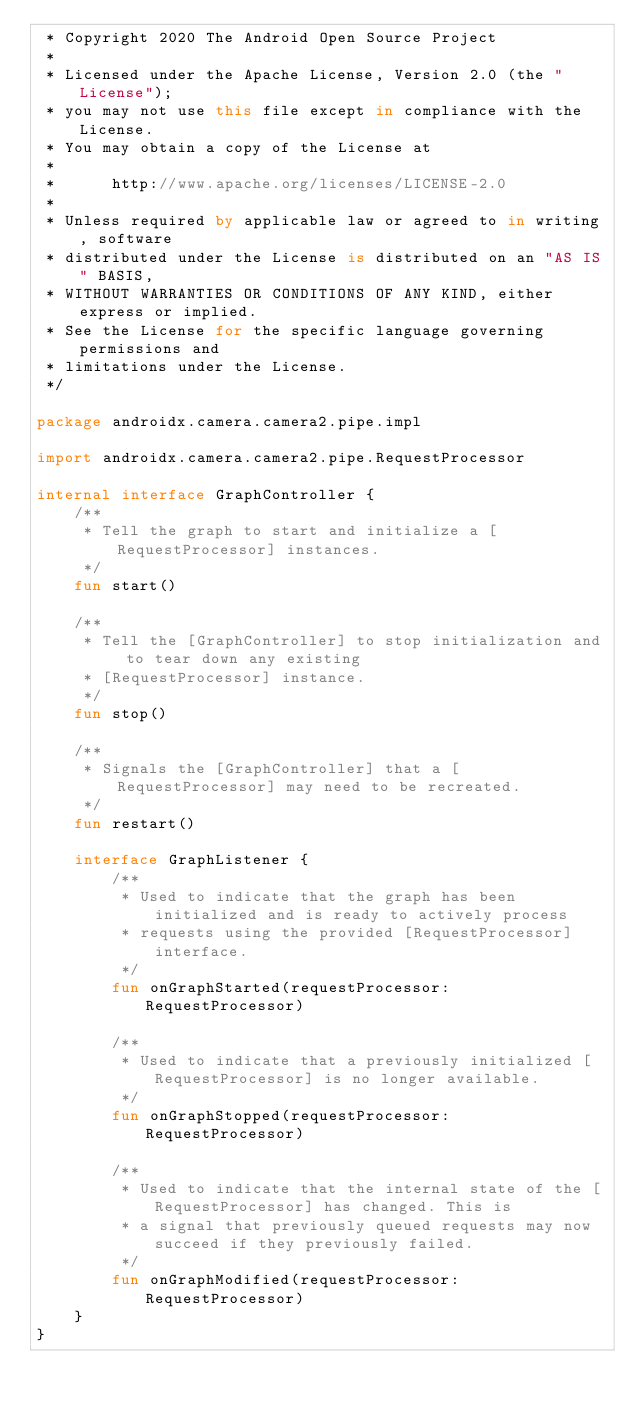Convert code to text. <code><loc_0><loc_0><loc_500><loc_500><_Kotlin_> * Copyright 2020 The Android Open Source Project
 *
 * Licensed under the Apache License, Version 2.0 (the "License");
 * you may not use this file except in compliance with the License.
 * You may obtain a copy of the License at
 *
 *      http://www.apache.org/licenses/LICENSE-2.0
 *
 * Unless required by applicable law or agreed to in writing, software
 * distributed under the License is distributed on an "AS IS" BASIS,
 * WITHOUT WARRANTIES OR CONDITIONS OF ANY KIND, either express or implied.
 * See the License for the specific language governing permissions and
 * limitations under the License.
 */

package androidx.camera.camera2.pipe.impl

import androidx.camera.camera2.pipe.RequestProcessor

internal interface GraphController {
    /**
     * Tell the graph to start and initialize a [RequestProcessor] instances.
     */
    fun start()

    /**
     * Tell the [GraphController] to stop initialization and to tear down any existing
     * [RequestProcessor] instance.
     */
    fun stop()

    /**
     * Signals the [GraphController] that a [RequestProcessor] may need to be recreated.
     */
    fun restart()

    interface GraphListener {
        /**
         * Used to indicate that the graph has been initialized and is ready to actively process
         * requests using the provided [RequestProcessor] interface.
         */
        fun onGraphStarted(requestProcessor: RequestProcessor)

        /**
         * Used to indicate that a previously initialized [RequestProcessor] is no longer available.
         */
        fun onGraphStopped(requestProcessor: RequestProcessor)

        /**
         * Used to indicate that the internal state of the [RequestProcessor] has changed. This is
         * a signal that previously queued requests may now succeed if they previously failed.
         */
        fun onGraphModified(requestProcessor: RequestProcessor)
    }
}
</code> 